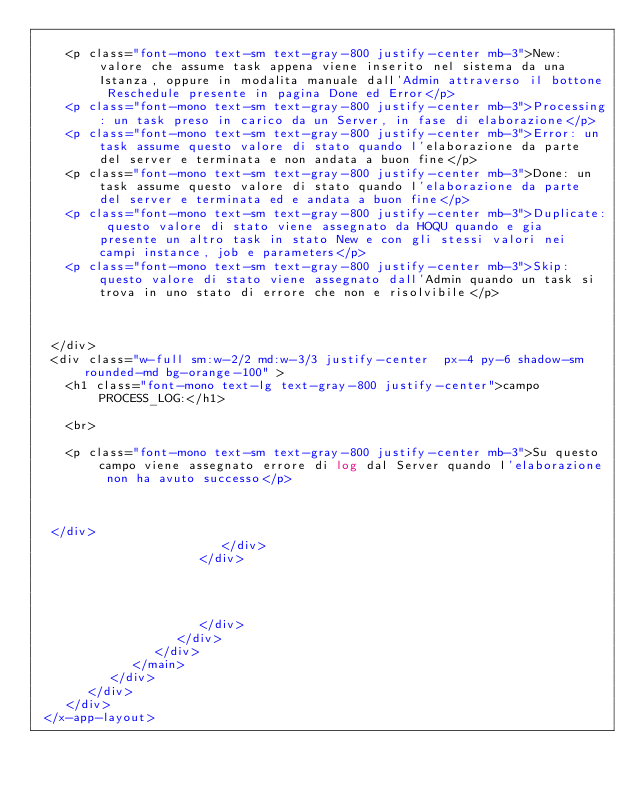Convert code to text. <code><loc_0><loc_0><loc_500><loc_500><_PHP_>
    <p class="font-mono text-sm text-gray-800 justify-center mb-3">New: valore che assume task appena viene inserito nel sistema da una Istanza, oppure in modalita manuale dall'Admin attraverso il bottone Reschedule presente in pagina Done ed Error</p>
    <p class="font-mono text-sm text-gray-800 justify-center mb-3">Processing: un task preso in carico da un Server, in fase di elaborazione</p>
    <p class="font-mono text-sm text-gray-800 justify-center mb-3">Error: un task assume questo valore di stato quando l'elaborazione da parte del server e terminata e non andata a buon fine</p>
    <p class="font-mono text-sm text-gray-800 justify-center mb-3">Done: un task assume questo valore di stato quando l'elaborazione da parte del server e terminata ed e andata a buon fine</p>
    <p class="font-mono text-sm text-gray-800 justify-center mb-3">Duplicate: questo valore di stato viene assegnato da HOQU quando e gia presente un altro task in stato New e con gli stessi valori nei campi instance, job e parameters</p>
    <p class="font-mono text-sm text-gray-800 justify-center mb-3">Skip: questo valore di stato viene assegnato dall'Admin quando un task si trova in uno stato di errore che non e risolvibile</p>



  </div>
  <div class="w-full sm:w-2/2 md:w-3/3 justify-center  px-4 py-6 shadow-sm rounded-md bg-orange-100" >
    <h1 class="font-mono text-lg text-gray-800 justify-center">campo PROCESS_LOG:</h1>

    <br>

    <p class="font-mono text-sm text-gray-800 justify-center mb-3">Su questo campo viene assegnato errore di log dal Server quando l'elaborazione non ha avuto successo</p>



  </div>
                         </div>
                      </div>




                      </div>
                   </div>
                </div>
             </main>
          </div>
       </div>
    </div>
 </x-app-layout>
</code> 